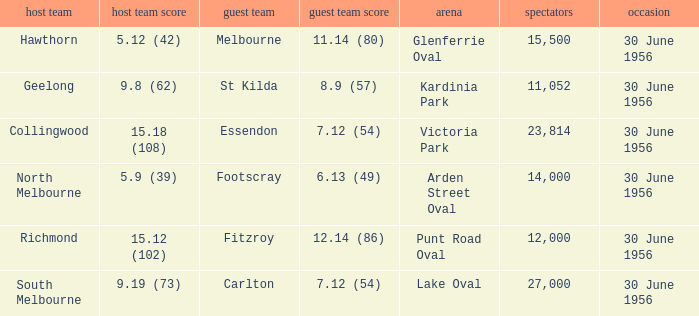What is the home team for punt road oval? Richmond. 